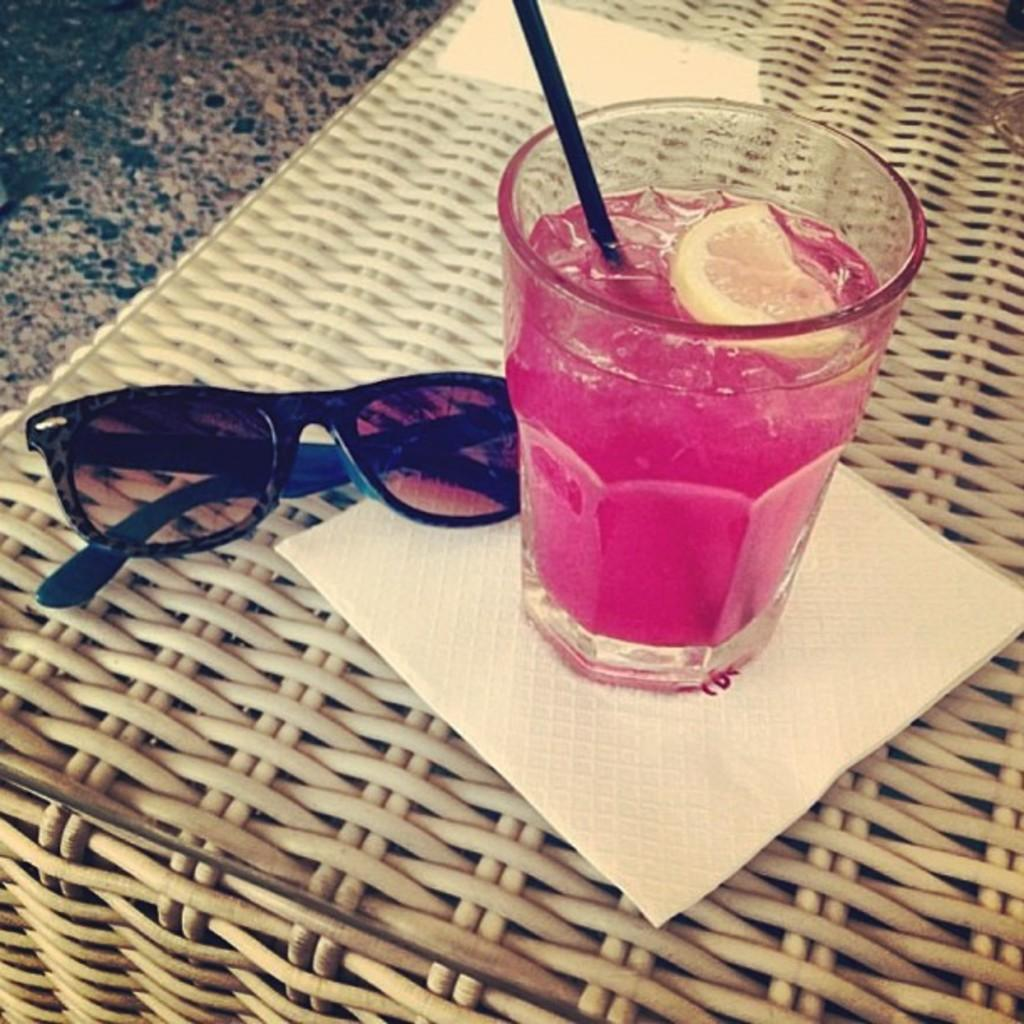What type of furniture is present in the image? There is a table in the image. Where is the table located? The table is on the floor. What is on the table in the image? There is a glass of juice, tissue, and sunglasses on the table. What type of calendar is hanging on the wall in the image? There is no calendar present in the image. Can you see a ship in the image? There is no ship present in the image. 